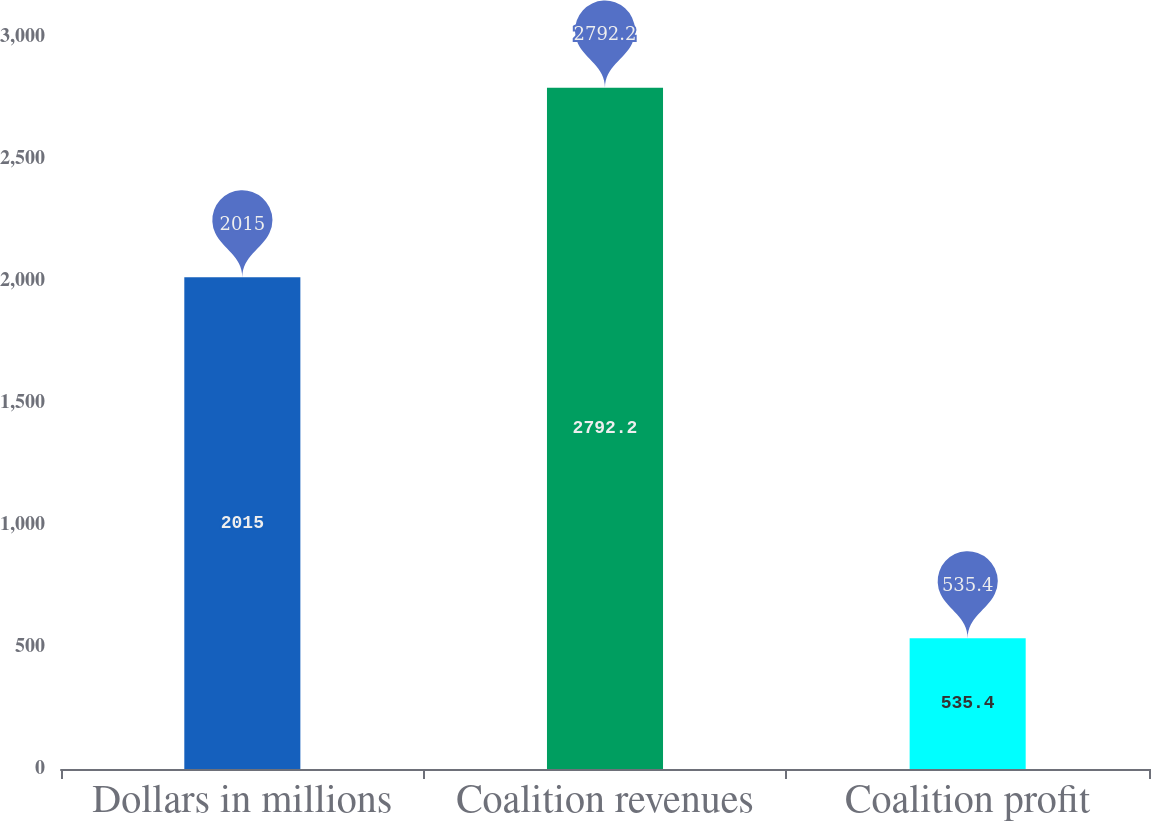<chart> <loc_0><loc_0><loc_500><loc_500><bar_chart><fcel>Dollars in millions<fcel>Coalition revenues<fcel>Coalition profit<nl><fcel>2015<fcel>2792.2<fcel>535.4<nl></chart> 